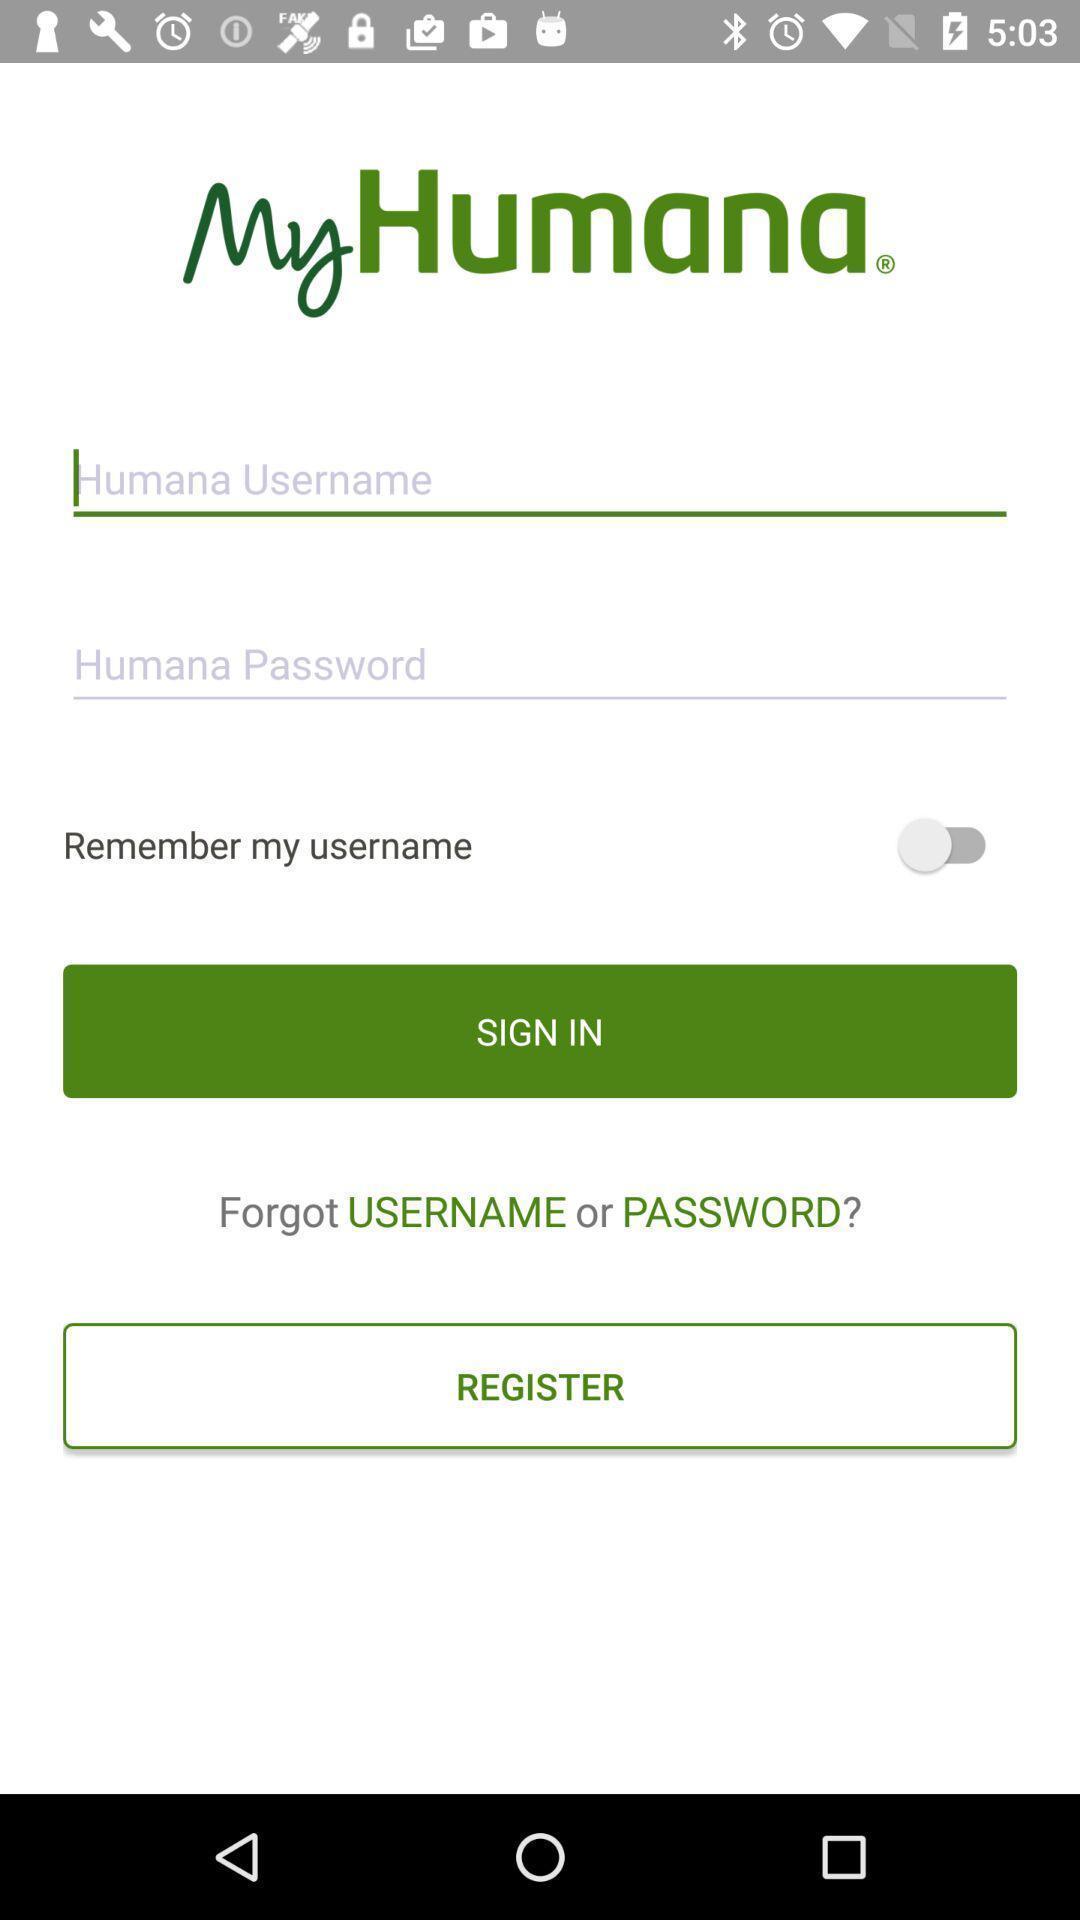Explain what's happening in this screen capture. Sign in page. 